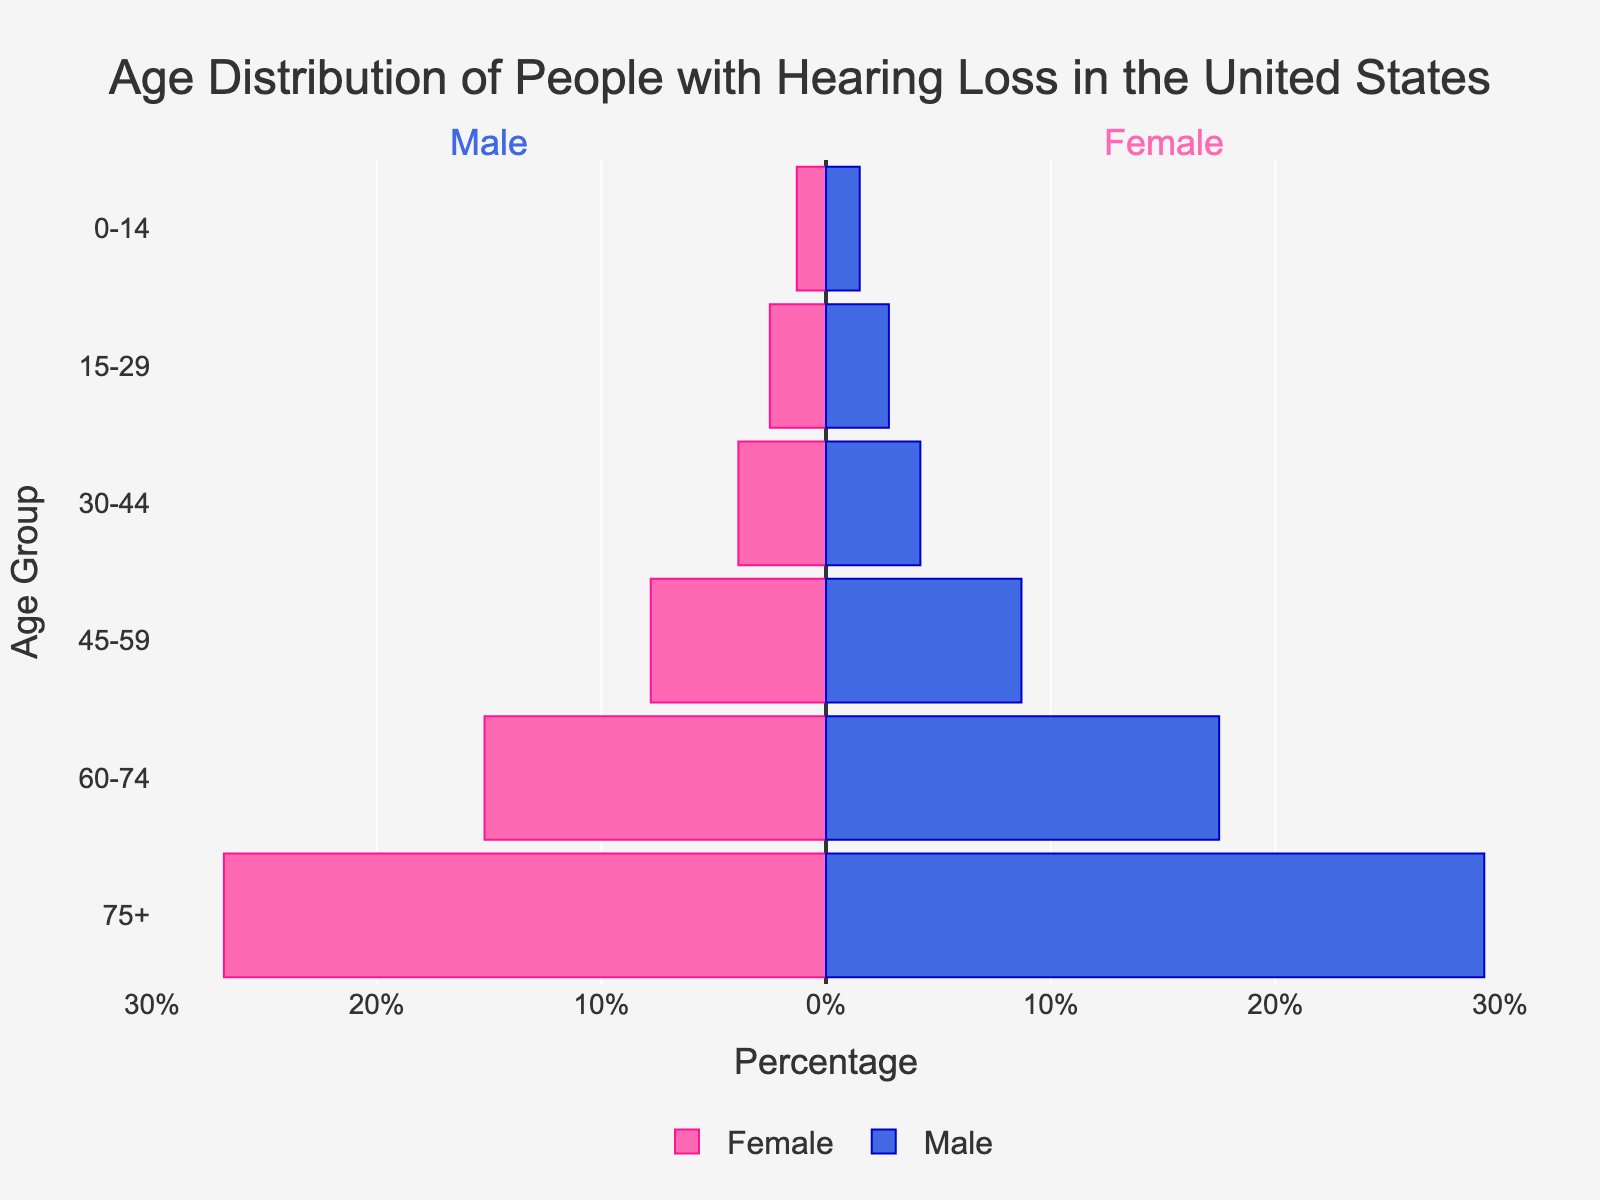What does the title of the figure indicate? The title of the figure is "Age Distribution of People with Hearing Loss in the United States." This indicates that the figure shows the age distribution of people with hearing loss in the U.S., separated by gender.
Answer: Age Distribution of People with Hearing Loss in the United States What do the bars in the figure represent? The bars represent the percentage of people with hearing loss within specific age groups, separated into male and female categories. The bars pointing to the left indicate males, and the bars pointing to the right indicate females.
Answer: Percentages of people with hearing loss within age groups by gender Which gender has a higher percentage of hearing loss in the 60-74 age group? By comparing the lengths of the bars for the 60-74 age group, the blue bar for males (-17.5%) is longer than the pink bar for females (-15.2%). Thus, males have a higher percentage of hearing loss in this age group.
Answer: Males What age group has the highest percentage of hearing loss for males? By analyzing the lengths of the blue bars, the 75+ age group has the longest bar at -29.3%, indicating the highest percentage of hearing loss for males in this group.
Answer: 75+ Is the percentage of hearing loss for females in the 0-14 age group higher or lower than that for males? By comparing the lengths of the bars for the 0-14 age group, the pink bar for females (-1.3%) is slightly shorter than the blue bar for males (-1.5%). Therefore, the percentage of hearing loss for females is lower than that for males in this age group.
Answer: Lower What is the combined percentage of people with hearing loss in the 60-74 age group for both genders? The percentage for males is -17.5% and for females is -15.2%. Summing these values (absolute values) gives 17.5% + 15.2% = 32.7%.
Answer: 32.7% How does the percentage of hearing loss in the 45-59 age group compare between males and females? The blue bar for males is at -8.7%, and the pink bar for females is at -7.8%. Comparing these percentages, males have a slightly higher percentage of hearing loss than females in the 45-59 age group.
Answer: Males have a slightly higher percentage What trend can be observed with age and hearing loss percentages for both genders? Observing the figure, as age increases, the percentage of people with hearing loss also increases for both males and females. The bars progressively get longer from the younger age groups to the older age groups.
Answer: Hearing loss percentage increases with age for both genders 